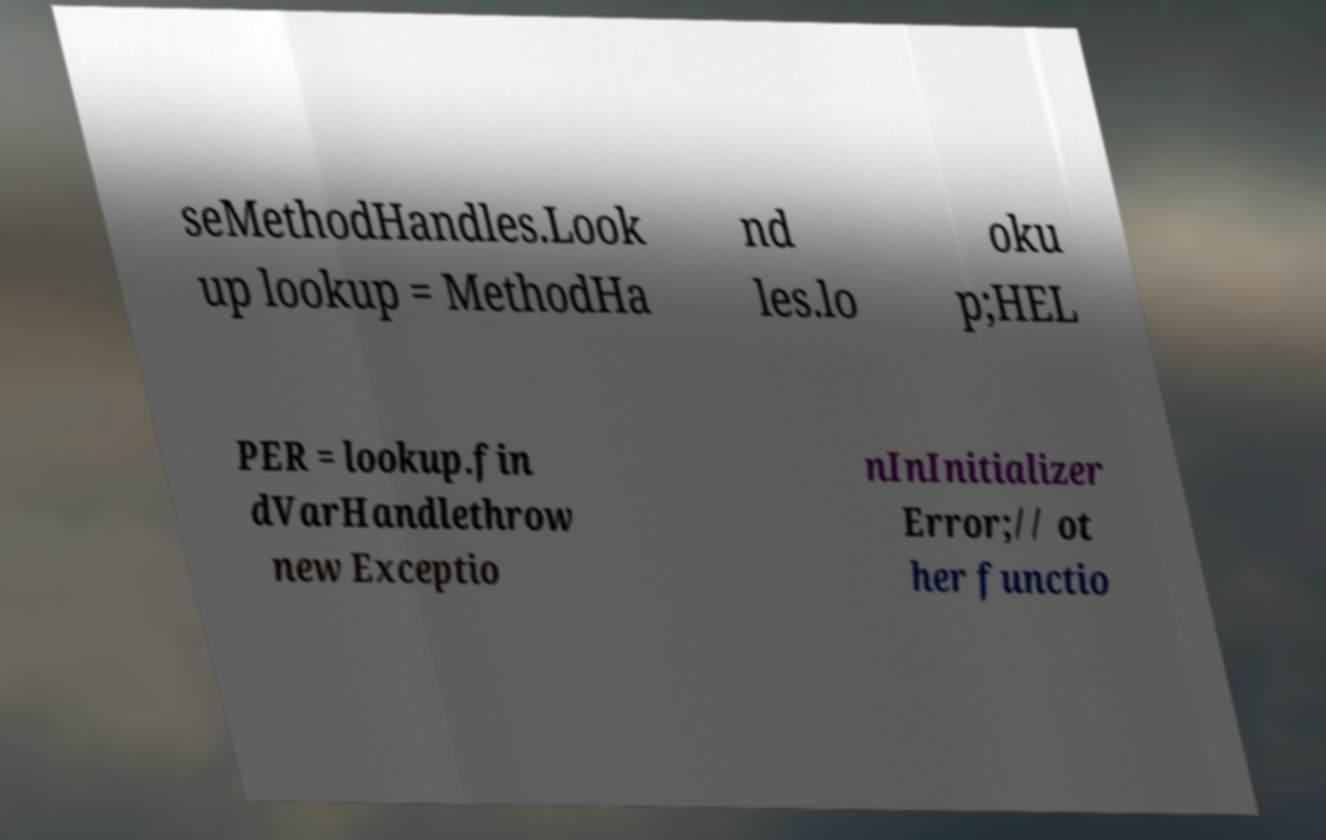For documentation purposes, I need the text within this image transcribed. Could you provide that? seMethodHandles.Look up lookup = MethodHa nd les.lo oku p;HEL PER = lookup.fin dVarHandlethrow new Exceptio nInInitializer Error;// ot her functio 